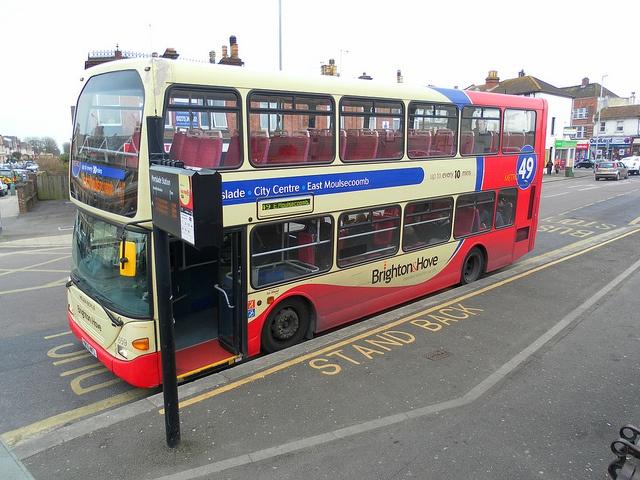Describe the objects in this image and their specific colors. I can see bus in white, black, gray, and beige tones, chair in white, gray, and black tones, chair in white, brown, darkgray, and gray tones, chair in white and brown tones, and chair in white and brown tones in this image. 